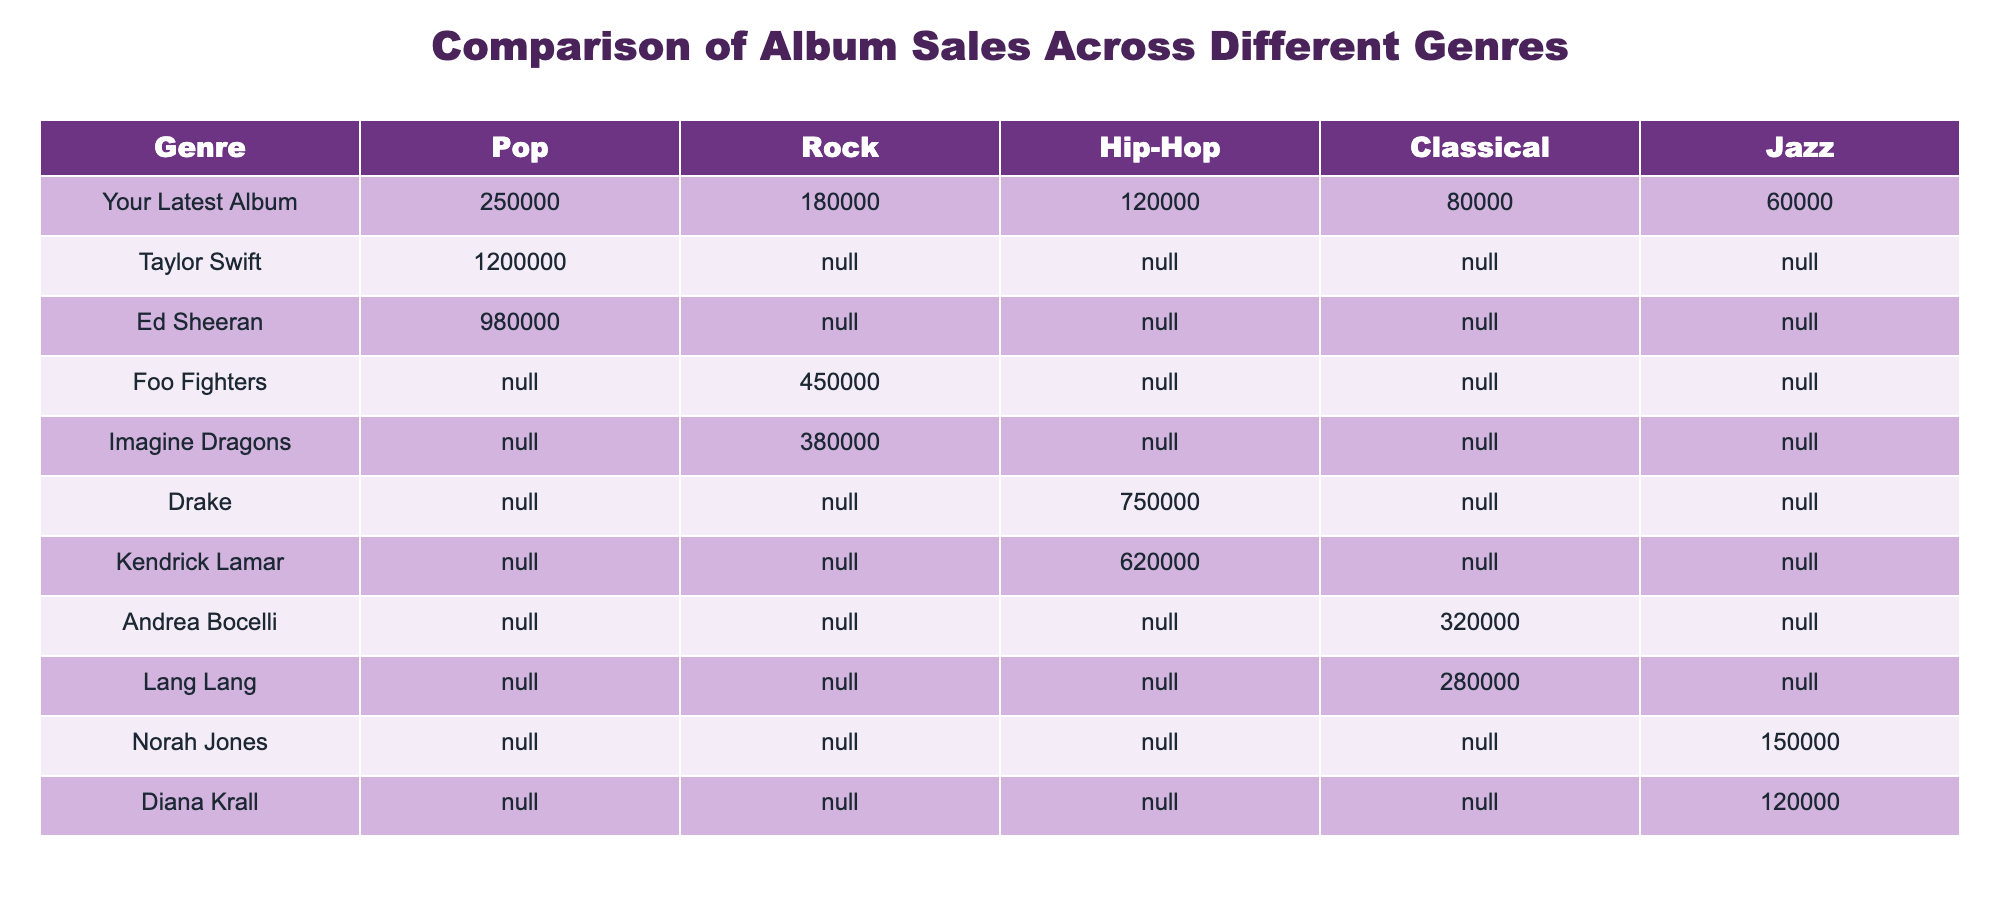What is the highest selling album in the Pop genre? The table indicates that Taylor Swift's album has 1,200,000 sales in the Pop genre, which is the highest value listed.
Answer: Taylor Swift How many albums have more than 300,000 sales in any genre? In the table, Taylor Swift (1,200,000), Ed Sheeran (980,000), Drake (750,000), and Foo Fighters (450,000) have sales of more than 300,000 in their respective genres. That totals 4 albums.
Answer: 4 Is your latest album the highest selling in the Jazz genre? Looking at the table, your latest album has 60,000 sales in Jazz, while Norah Jones has 150,000 and Diana Krall has 120,000. Therefore, your album is not the highest in the Jazz genre.
Answer: No What is the total sales of albums in the Rock genre? In the Rock genre, the sales are: Foo Fighters (450,000), Imagine Dragons (380,000), and your latest album (180,000). Summing these gives: 450,000 + 380,000 + 180,000 = 1,010,000.
Answer: 1,010,000 Which genre has the lowest total sales across all albums listed? The genre with the lowest sales is Jazz, with only your latest album (60,000), Norah Jones (150,000), and Diana Krall (120,000), giving a total of 330,000. All other genres exceed this total.
Answer: Jazz What is the average sales of albums in the Hip-Hop genre? The Hip-Hop sales are from Drake (750,000) and Kendrick Lamar (620,000). The average is calculated as (750,000 + 620,000) / 2 = 685,000.
Answer: 685,000 How many artists had albums that sold over 200,000 copies in the Classical genre? In Classical, only Andrea Bocelli (320,000) and Lang Lang (280,000) exceed 200,000 copies, amounting to 2 artists.
Answer: 2 Is Ed Sheeran's album the only one without any values in the Rock genre? The table shows that Ed Sheeran has no sales listed in the Rock genre (denoted by N/A), confirming that he is indeed the only artist without any recorded sales in that genre.
Answer: Yes What is the difference in sales between your latest album and that of Andrea Bocelli in the Classical genre? Your latest album sold 80,000 copies while Andrea Bocelli sold 320,000. The difference is calculated as 320,000 - 80,000 = 240,000.
Answer: 240,000 